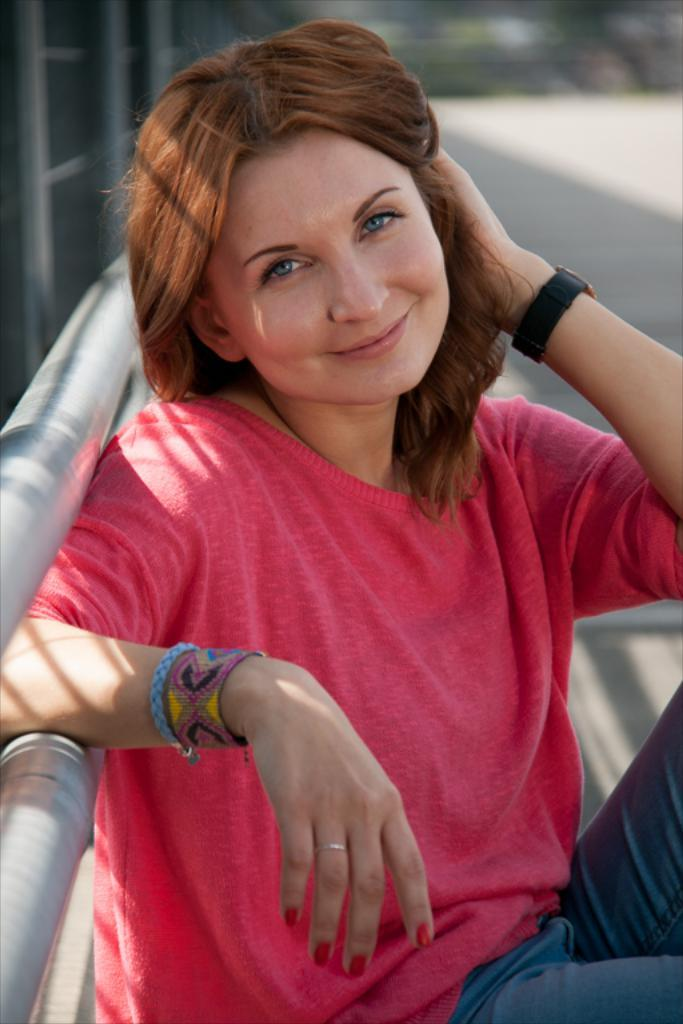Who is present in the image? There is a woman in the image. What is the woman wearing? The woman is wearing a pink t-shirt. What is the woman's facial expression? The woman is smiling. What is the woman doing in the image? The woman is sitting and laying a hand on a pipe. Can you describe the background of the image? The background of the image is blurred. What month is depicted in the image? There is no specific month depicted in the image; it is a photograph of a woman sitting and interacting with a pipe. Can you see a plane in the image? There is no plane present in the image. 